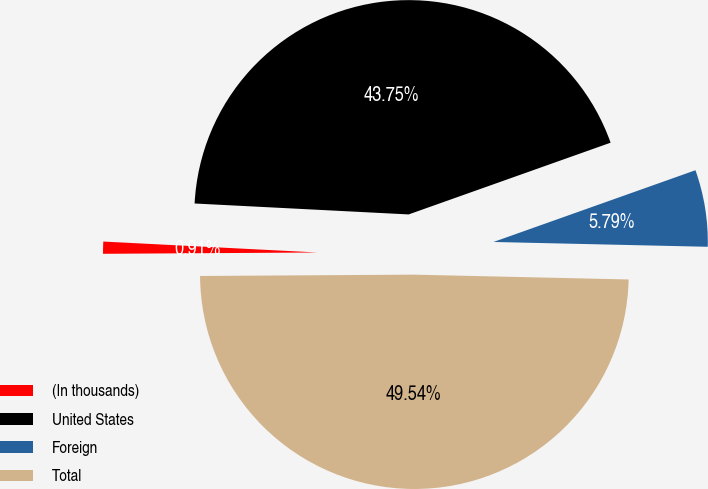Convert chart. <chart><loc_0><loc_0><loc_500><loc_500><pie_chart><fcel>(In thousands)<fcel>United States<fcel>Foreign<fcel>Total<nl><fcel>0.91%<fcel>43.75%<fcel>5.79%<fcel>49.54%<nl></chart> 